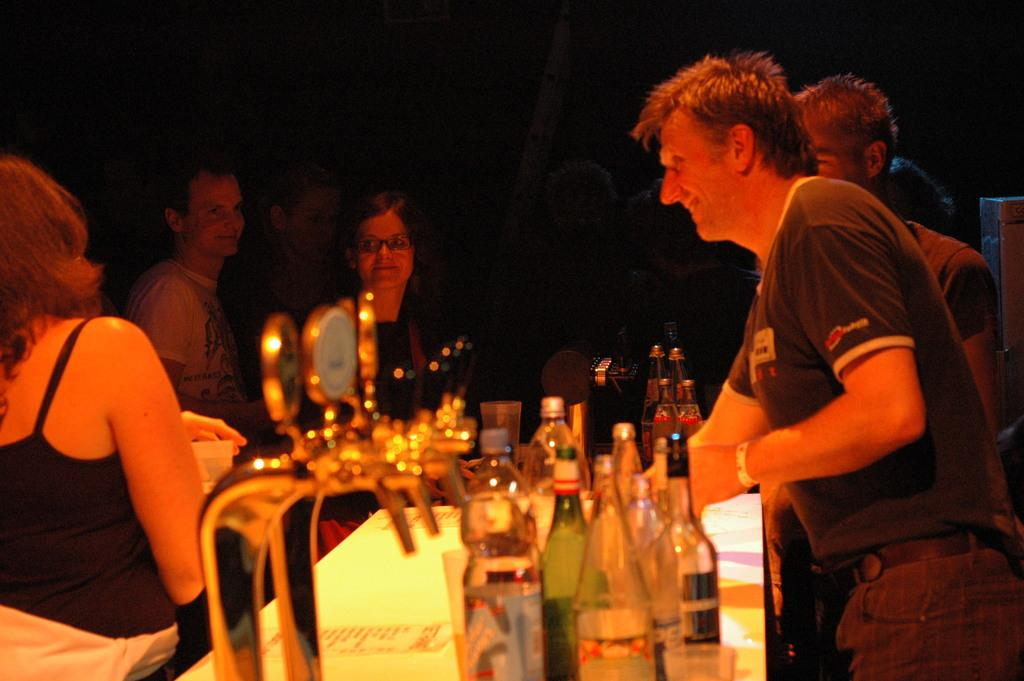How many people are in the image? There is a group of persons in the image. What are the persons in the image doing? The persons are standing. What object can be seen on the table in the image? There is a bottle on the table. What is the woman on the left side of the image holding? A woman is holding a cup on the left side of the image. What type of roof is visible in the image? There is no roof visible in the image. How does the woman's uncle feel about her holding a cup in the image? There is no information about the woman's uncle or his feelings in the image. 